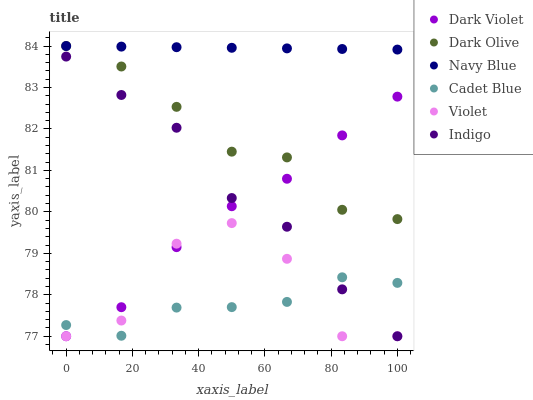Does Cadet Blue have the minimum area under the curve?
Answer yes or no. Yes. Does Navy Blue have the maximum area under the curve?
Answer yes or no. Yes. Does Indigo have the minimum area under the curve?
Answer yes or no. No. Does Indigo have the maximum area under the curve?
Answer yes or no. No. Is Navy Blue the smoothest?
Answer yes or no. Yes. Is Violet the roughest?
Answer yes or no. Yes. Is Indigo the smoothest?
Answer yes or no. No. Is Indigo the roughest?
Answer yes or no. No. Does Indigo have the lowest value?
Answer yes or no. Yes. Does Navy Blue have the lowest value?
Answer yes or no. No. Does Dark Olive have the highest value?
Answer yes or no. Yes. Does Indigo have the highest value?
Answer yes or no. No. Is Indigo less than Navy Blue?
Answer yes or no. Yes. Is Navy Blue greater than Indigo?
Answer yes or no. Yes. Does Violet intersect Cadet Blue?
Answer yes or no. Yes. Is Violet less than Cadet Blue?
Answer yes or no. No. Is Violet greater than Cadet Blue?
Answer yes or no. No. Does Indigo intersect Navy Blue?
Answer yes or no. No. 